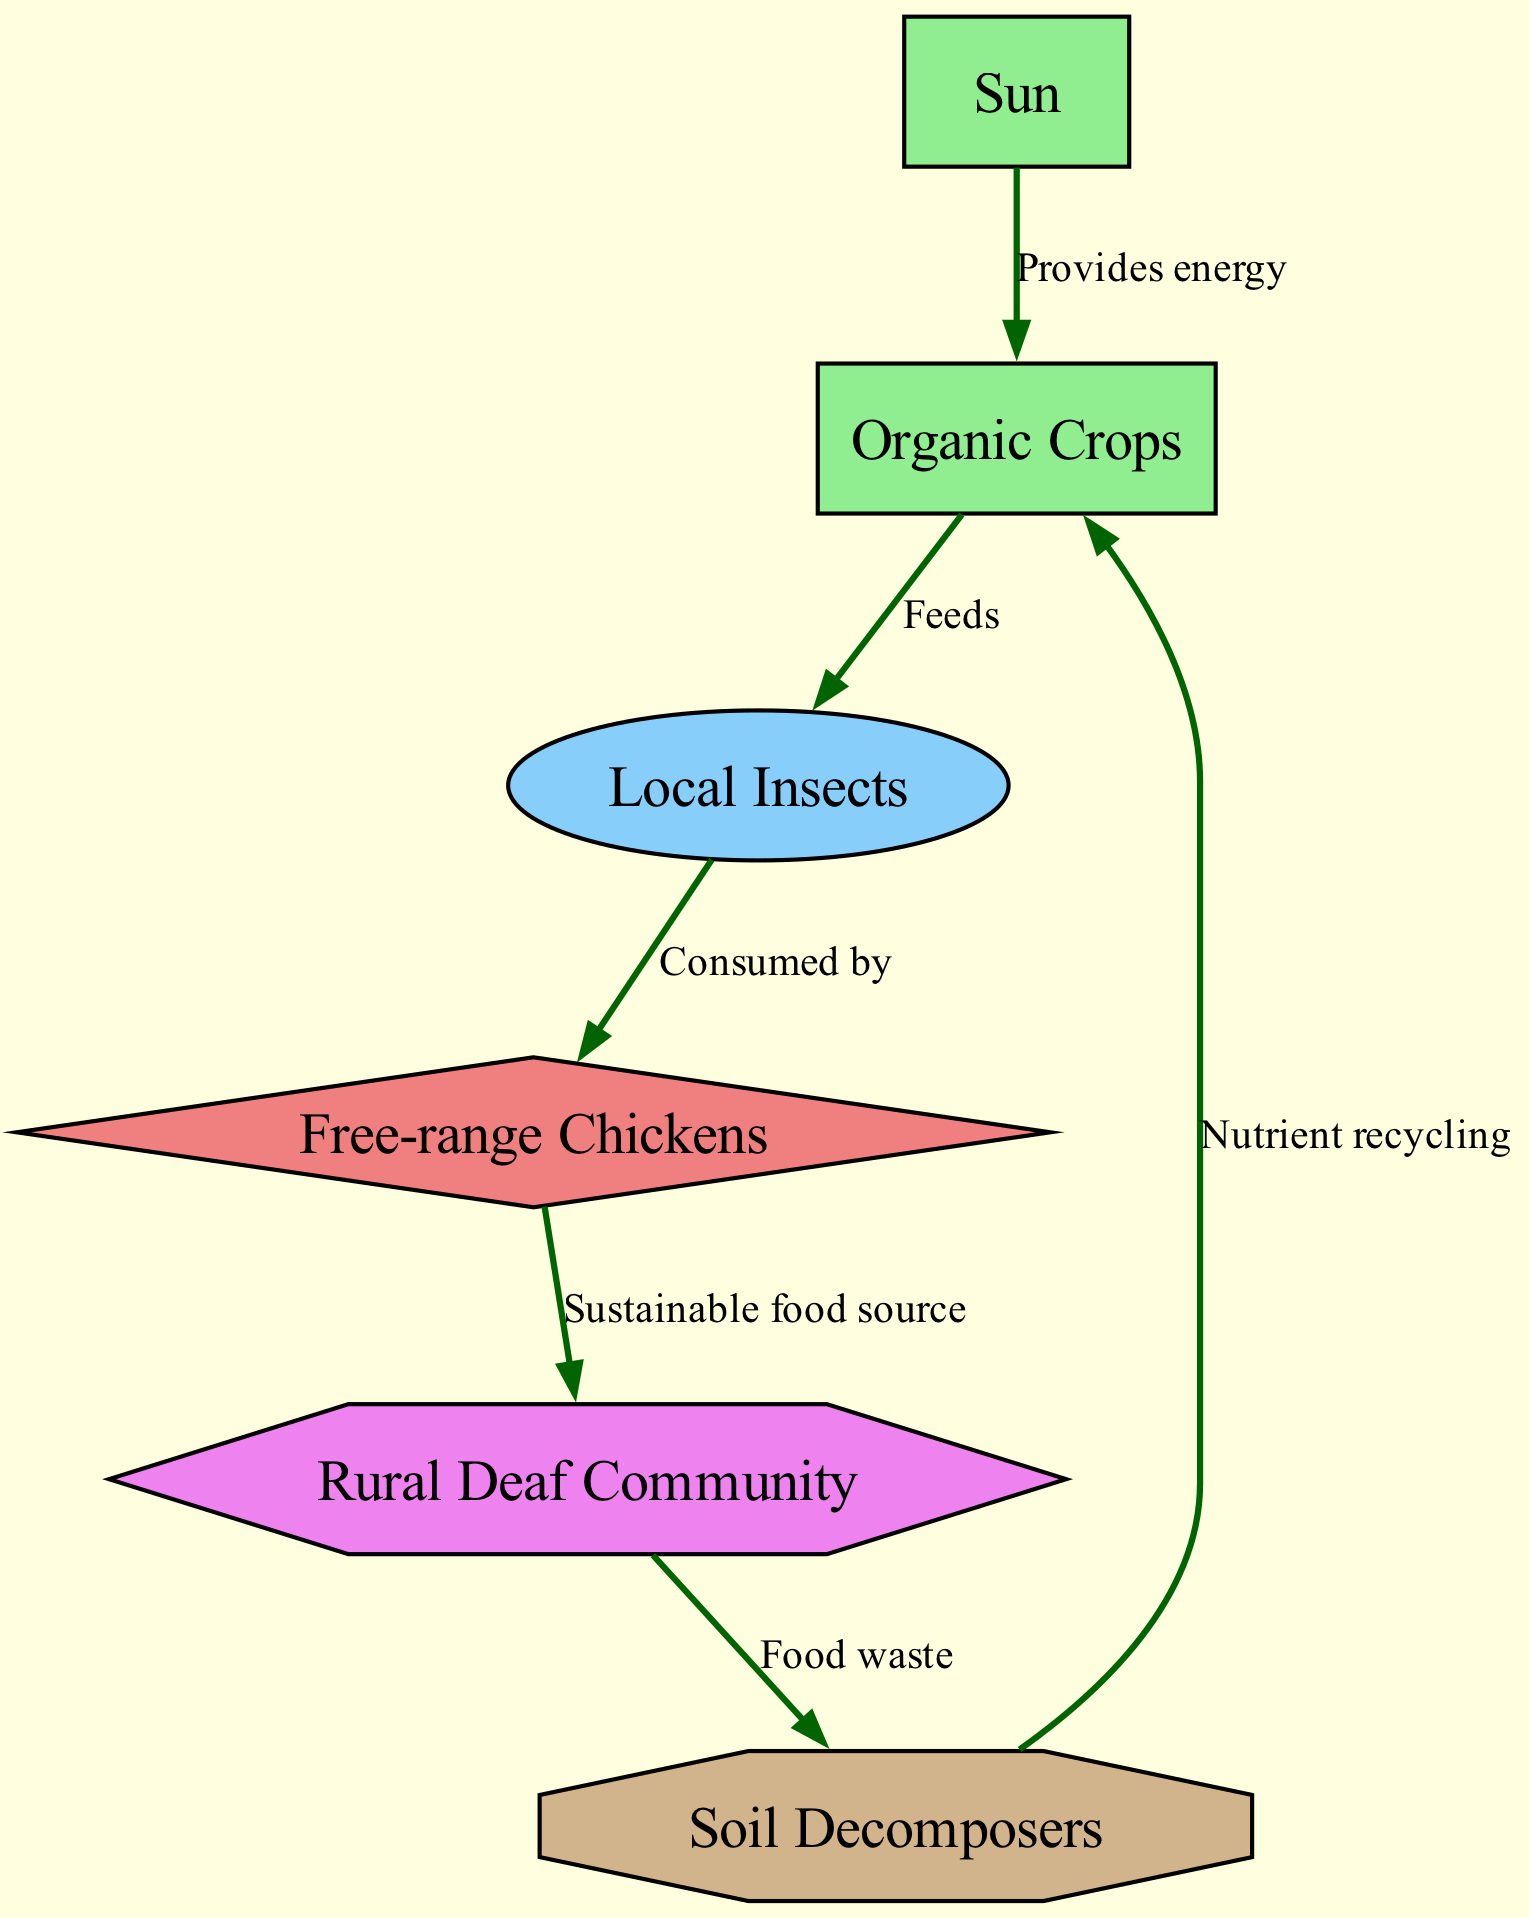What is the first element in the food chain? The first element is the "Sun," which provides energy for organic crops.
Answer: Sun How many primary consumers are there? There is one primary consumer, which is "Local Insects".
Answer: 1 Which element supports "Free-range Chickens"? "Local Insects" are consumed by "Free-range Chickens".
Answer: Local Insects What role does "Soil Decomposers" play in the ecosystem? "Soil Decomposers" are responsible for nutrient recycling, converting food waste back into nutrients that support organic crops.
Answer: Decomposer Describe the relationship between the "Rural Deaf Community" and "Soil Decomposers". The relationship is that the "Rural Deaf Community" produces food waste, which is then utilized by "Soil Decomposers".
Answer: Food waste What energy source do "Organic Crops" rely on? "Organic Crops" rely on energy provided by the "Sun."
Answer: Sun How do "Free-range Chickens" contribute to the diet of the "Rural Deaf Community"? "Free-range Chickens" act as a sustainable food source for the "Rural Deaf Community".
Answer: Sustainable food source What is recycled by "Soil Decomposers"? "Soil Decomposers" recycle nutrients back into "Organic Crops".
Answer: Nutrient recycling How many total elements are depicted in the food chain? There are a total of six elements in the food chain: Sun, Organic Crops, Local Insects, Free-range Chickens, Rural Deaf Community, and Soil Decomposers.
Answer: 6 